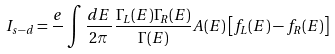Convert formula to latex. <formula><loc_0><loc_0><loc_500><loc_500>I _ { s - d } = \frac { e } { } \int \frac { d E } { 2 \pi } \, \frac { \Gamma _ { L } ( E ) \Gamma _ { R } ( E ) } { \Gamma ( E ) } A ( E ) \left [ f _ { L } ( E ) - f _ { R } ( E ) \right ]</formula> 